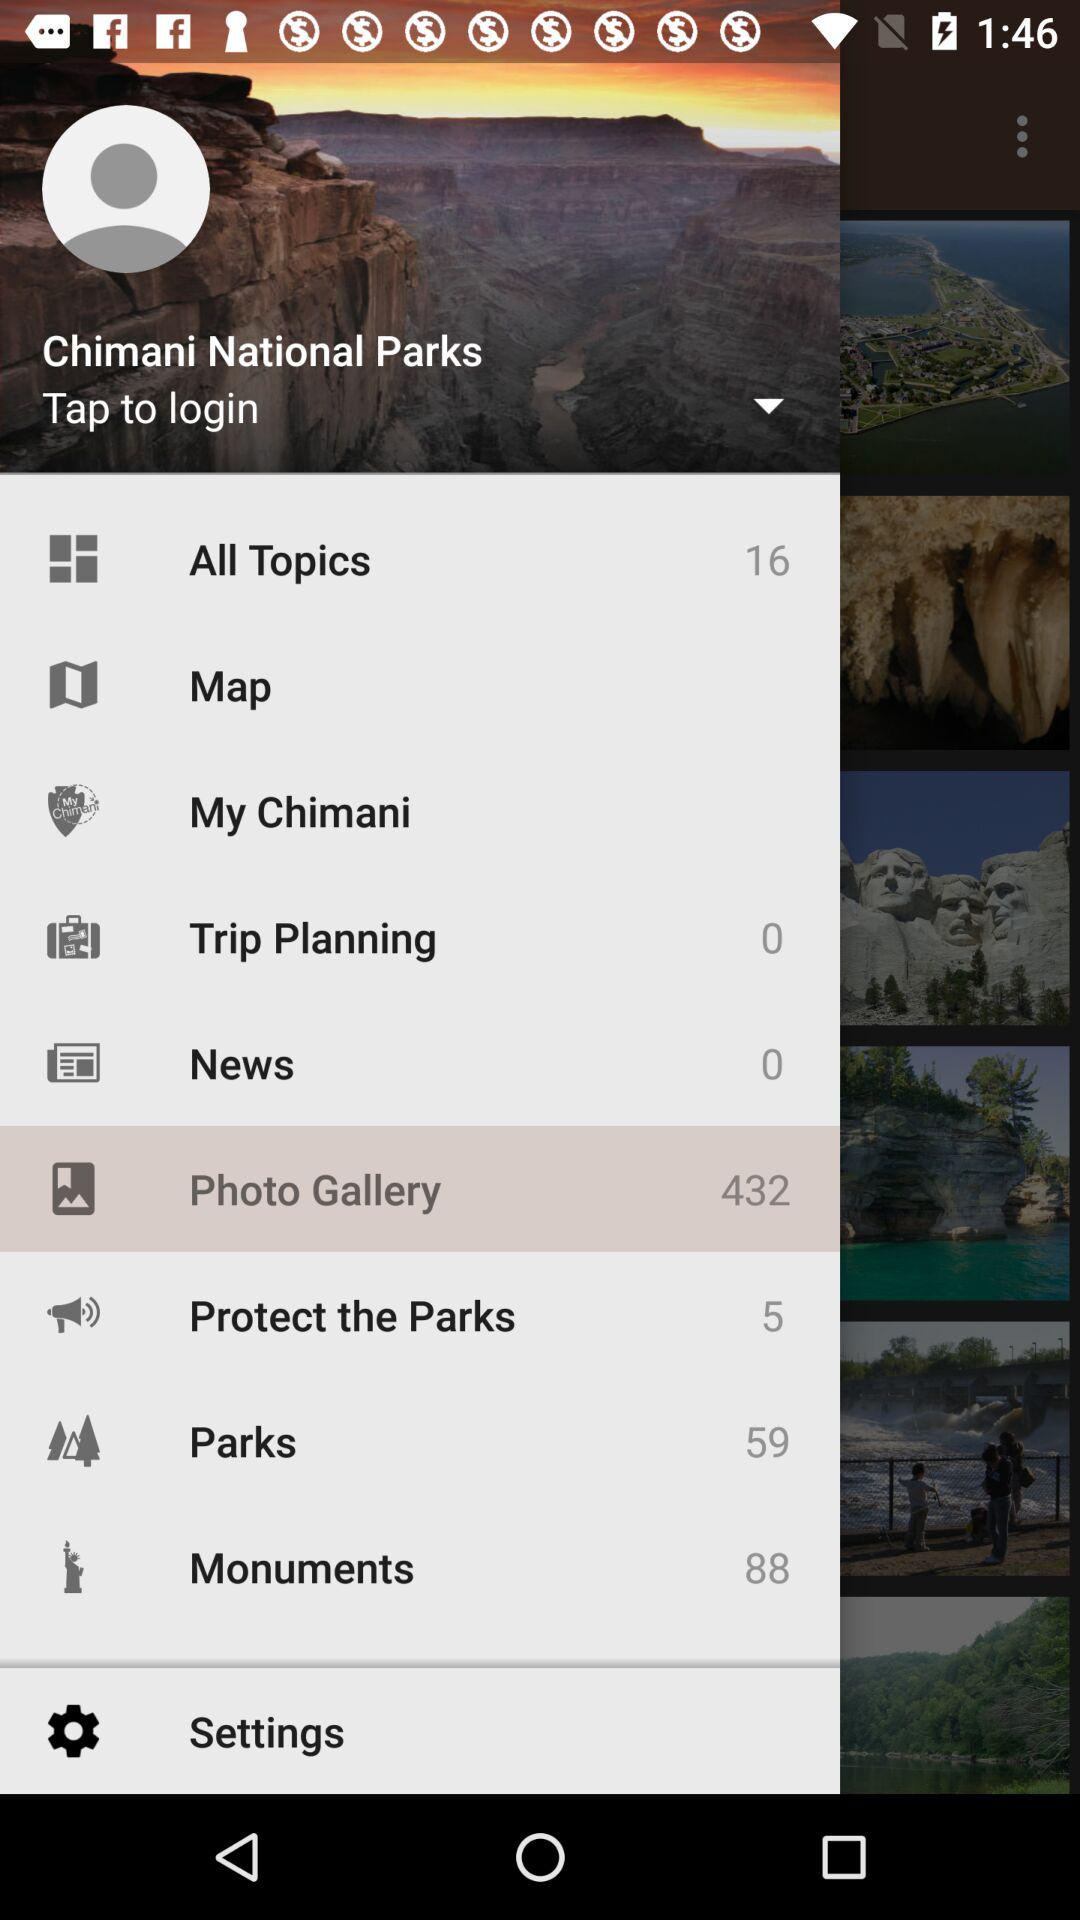What is the name of the National park?
When the provided information is insufficient, respond with <no answer>. <no answer> 